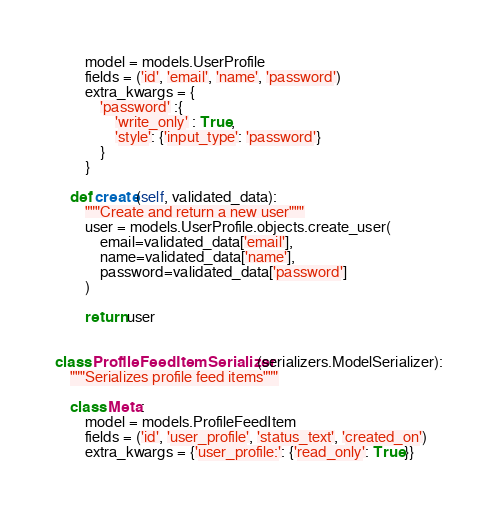<code> <loc_0><loc_0><loc_500><loc_500><_Python_>        model = models.UserProfile
        fields = ('id', 'email', 'name', 'password')
        extra_kwargs = {
            'password' :{
                'write_only' : True,
                'style': {'input_type': 'password'}
            }
        }

    def create(self, validated_data):
        """Create and return a new user"""
        user = models.UserProfile.objects.create_user(
            email=validated_data['email'],
            name=validated_data['name'],
            password=validated_data['password']
        )

        return user    


class ProfileFeedItemSerializer(serializers.ModelSerializer):
    """Serializes profile feed items"""

    class Meta:
        model = models.ProfileFeedItem
        fields = ('id', 'user_profile', 'status_text', 'created_on')
        extra_kwargs = {'user_profile:': {'read_only': True}}


</code> 